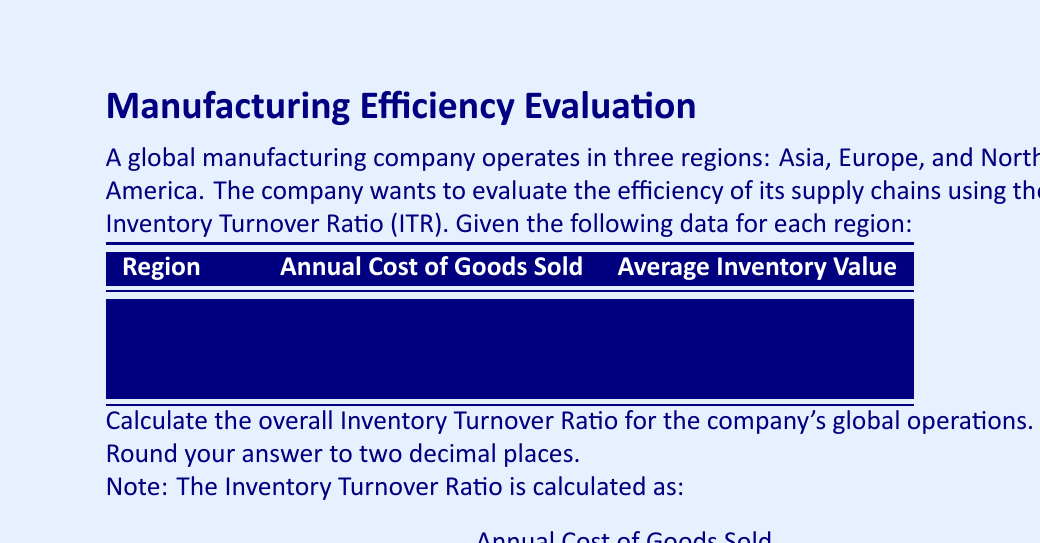Show me your answer to this math problem. To calculate the overall Inventory Turnover Ratio for the company's global operations, we need to:

1. Sum up the Annual Cost of Goods Sold for all regions:
   $720 + 540 + 480 = 1740$ million

2. Sum up the Average Inventory Value for all regions:
   $90 + 60 + 80 = 230$ million

3. Apply the ITR formula using the global totals:

   $$ ITR = \frac{\text{Total Annual Cost of Goods Sold}}{\text{Total Average Inventory Value}} $$

   $$ ITR = \frac{1740}{230} $$

4. Perform the division:
   $1740 \div 230 = 7.5652173913...$

5. Round to two decimal places:
   $7.57$

Therefore, the overall Inventory Turnover Ratio for the company's global operations is 7.57.
Answer: 7.57 